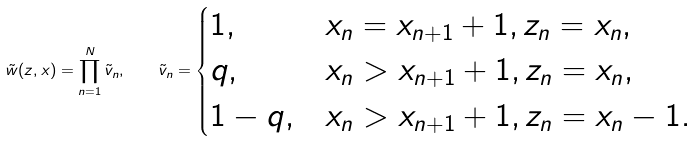Convert formula to latex. <formula><loc_0><loc_0><loc_500><loc_500>\tilde { w } ( z , x ) = \prod _ { n = 1 } ^ { N } \tilde { v } _ { n } , \quad \tilde { v } _ { n } = \begin{cases} 1 , & x _ { n } = x _ { n + 1 } + 1 , z _ { n } = x _ { n } , \\ q , & x _ { n } > x _ { n + 1 } + 1 , z _ { n } = x _ { n } , \\ 1 - q , & x _ { n } > x _ { n + 1 } + 1 , z _ { n } = x _ { n } - 1 . \end{cases}</formula> 